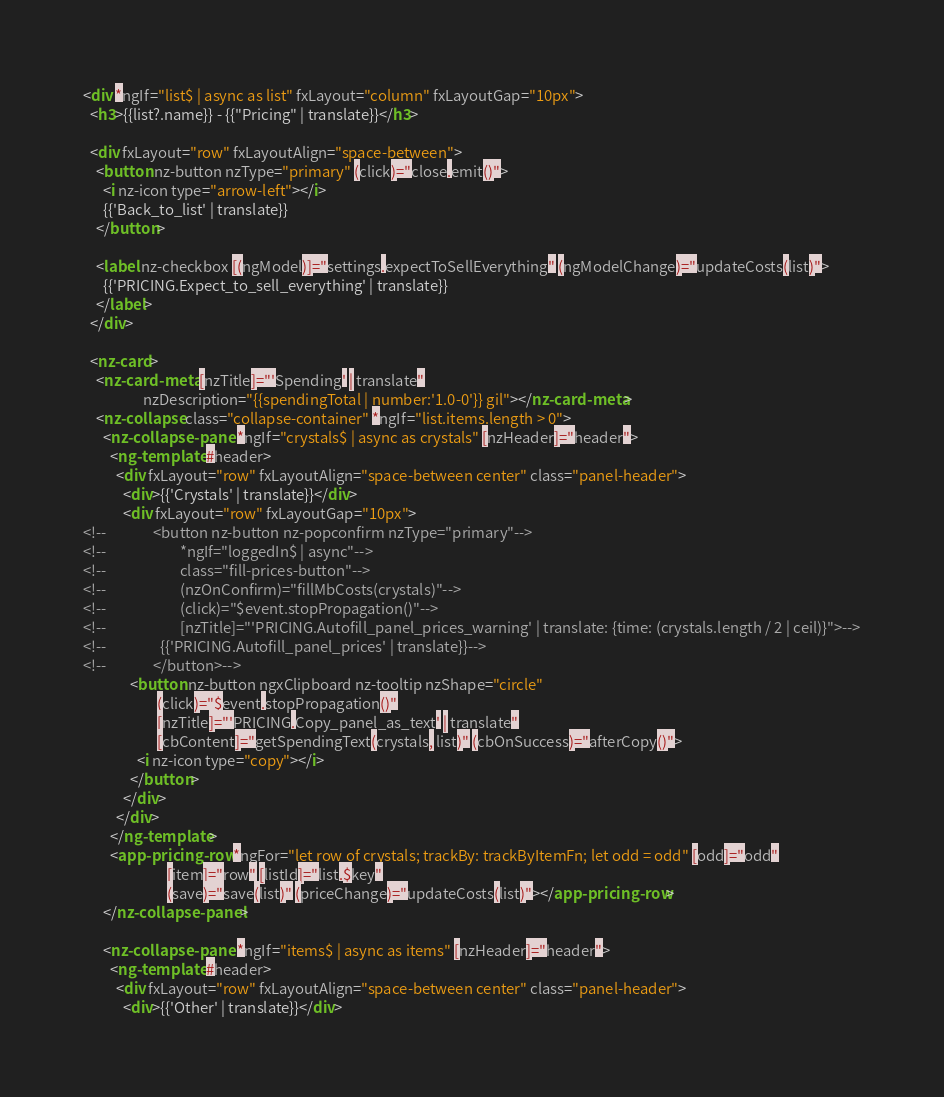<code> <loc_0><loc_0><loc_500><loc_500><_HTML_><div *ngIf="list$ | async as list" fxLayout="column" fxLayoutGap="10px">
  <h3>{{list?.name}} - {{"Pricing" | translate}}</h3>

  <div fxLayout="row" fxLayoutAlign="space-between">
    <button nz-button nzType="primary" (click)="close.emit()">
      <i nz-icon type="arrow-left"></i>
      {{'Back_to_list' | translate}}
    </button>

    <label nz-checkbox [(ngModel)]="settings.expectToSellEverything" (ngModelChange)="updateCosts(list)">
      {{'PRICING.Expect_to_sell_everything' | translate}}
    </label>
  </div>

  <nz-card>
    <nz-card-meta [nzTitle]="'Spending' | translate"
                  nzDescription="{{spendingTotal | number:'1.0-0'}} gil"></nz-card-meta>
    <nz-collapse class="collapse-container" *ngIf="list.items.length > 0">
      <nz-collapse-panel *ngIf="crystals$ | async as crystals" [nzHeader]="header">
        <ng-template #header>
          <div fxLayout="row" fxLayoutAlign="space-between center" class="panel-header">
            <div>{{'Crystals' | translate}}</div>
            <div fxLayout="row" fxLayoutGap="10px">
<!--              <button nz-button nz-popconfirm nzType="primary"-->
<!--                      *ngIf="loggedIn$ | async"-->
<!--                      class="fill-prices-button"-->
<!--                      (nzOnConfirm)="fillMbCosts(crystals)"-->
<!--                      (click)="$event.stopPropagation()"-->
<!--                      [nzTitle]="'PRICING.Autofill_panel_prices_warning' | translate: {time: (crystals.length / 2 | ceil)}">-->
<!--                {{'PRICING.Autofill_panel_prices' | translate}}-->
<!--              </button>-->
              <button nz-button ngxClipboard nz-tooltip nzShape="circle"
                      (click)="$event.stopPropagation()"
                      [nzTitle]="'PRICING.Copy_panel_as_text' | translate"
                      [cbContent]="getSpendingText(crystals, list)" (cbOnSuccess)="afterCopy()">
                <i nz-icon type="copy"></i>
              </button>
            </div>
          </div>
        </ng-template>
        <app-pricing-row *ngFor="let row of crystals; trackBy: trackByItemFn; let odd = odd" [odd]="odd"
                         [item]="row" [listId]="list.$key"
                         (save)="save(list)" (priceChange)="updateCosts(list)"></app-pricing-row>
      </nz-collapse-panel>

      <nz-collapse-panel *ngIf="items$ | async as items" [nzHeader]="header">
        <ng-template #header>
          <div fxLayout="row" fxLayoutAlign="space-between center" class="panel-header">
            <div>{{'Other' | translate}}</div></code> 